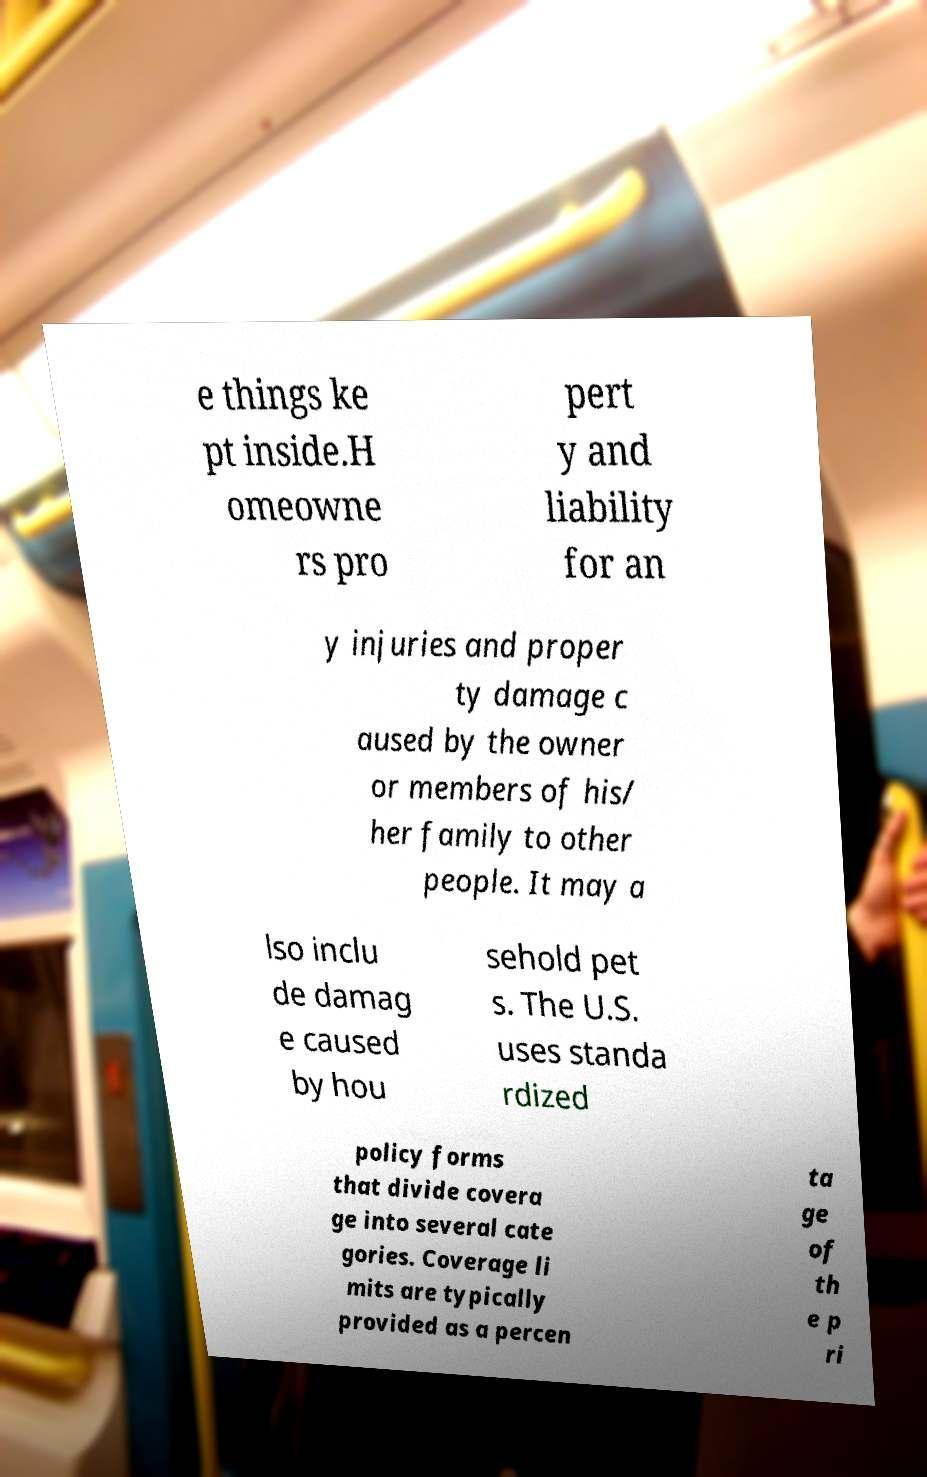What messages or text are displayed in this image? I need them in a readable, typed format. e things ke pt inside.H omeowne rs pro pert y and liability for an y injuries and proper ty damage c aused by the owner or members of his/ her family to other people. It may a lso inclu de damag e caused by hou sehold pet s. The U.S. uses standa rdized policy forms that divide covera ge into several cate gories. Coverage li mits are typically provided as a percen ta ge of th e p ri 